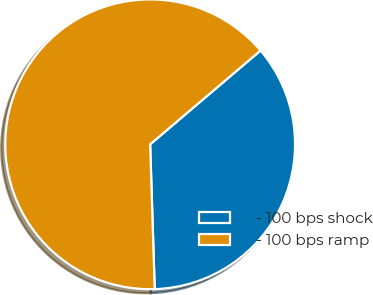Convert chart to OTSL. <chart><loc_0><loc_0><loc_500><loc_500><pie_chart><fcel>- 100 bps shock<fcel>- 100 bps ramp<nl><fcel>35.71%<fcel>64.29%<nl></chart> 